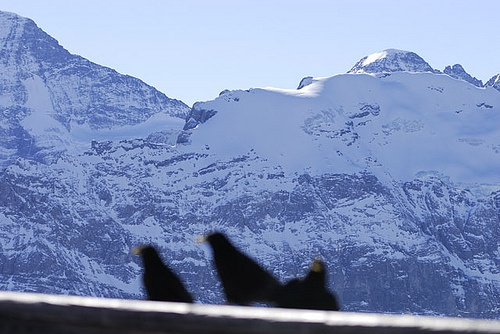Describe the objects in this image and their specific colors. I can see bird in lavender, black, navy, gray, and darkblue tones, bird in lavender, black, navy, gray, and darkblue tones, and bird in lavender, black, navy, gray, and darkblue tones in this image. 